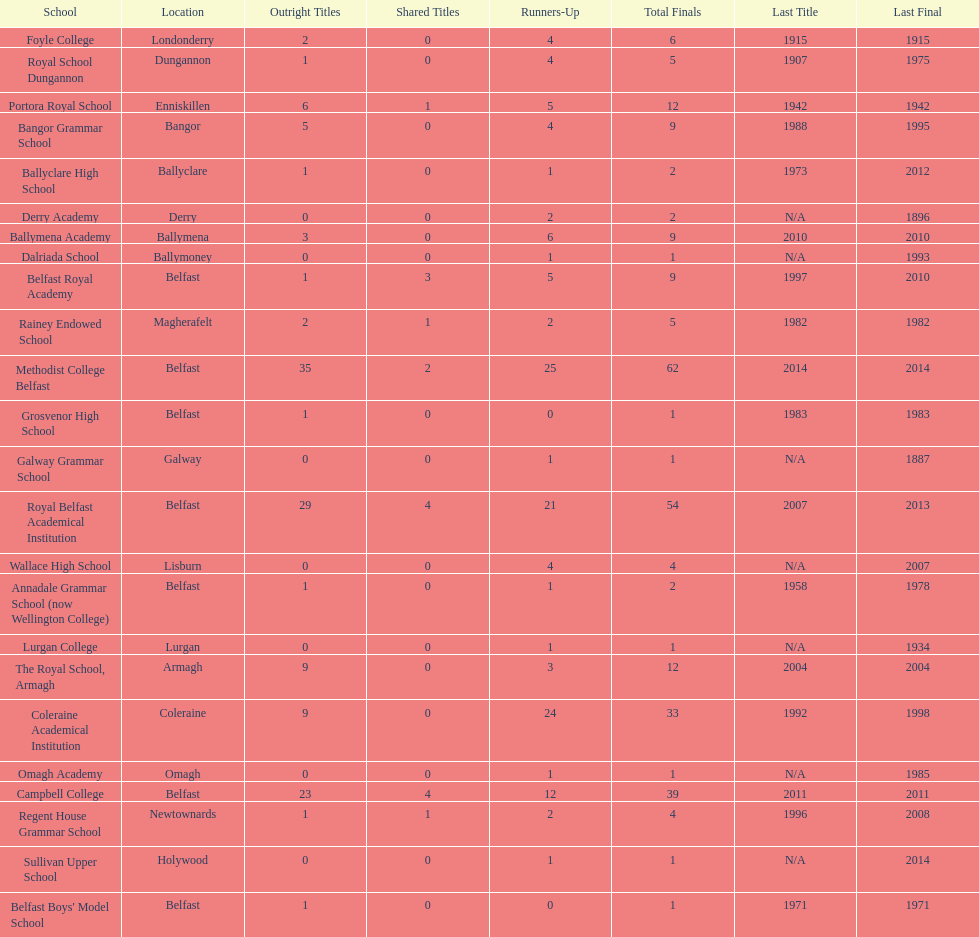Which two schools each had twelve total finals? The Royal School, Armagh, Portora Royal School. 